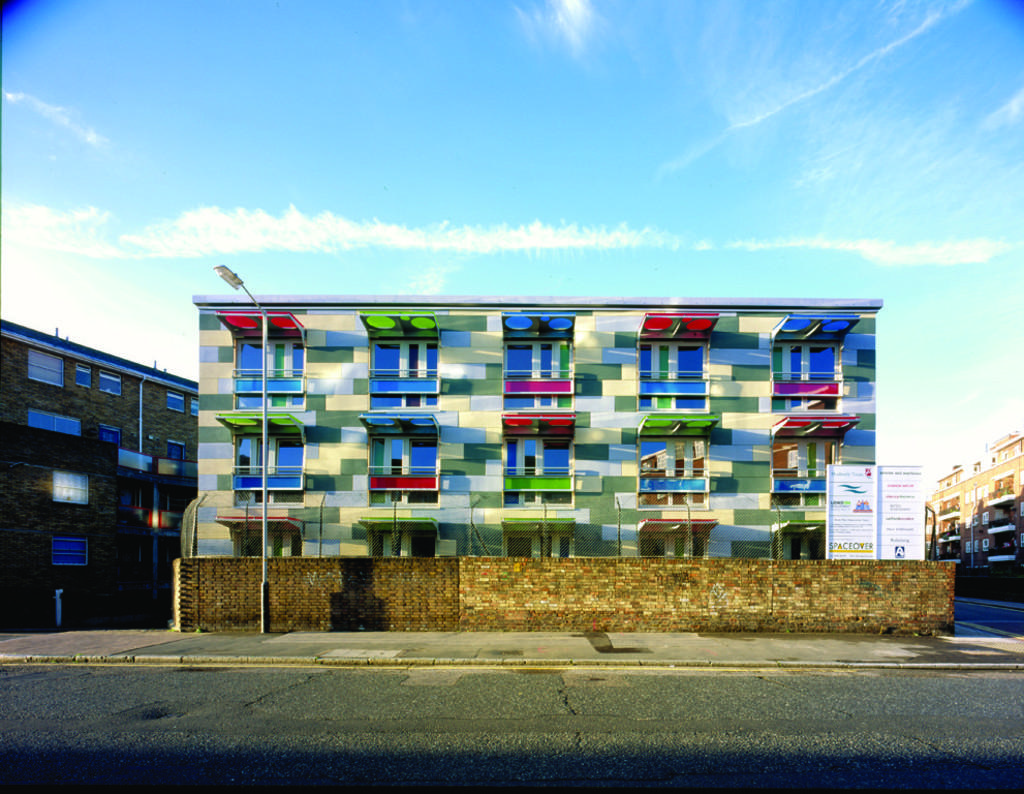What is the main subject in the center of the image? There is a building in the center of the image. Are there any other buildings visible in the image? Yes, there are other buildings on the right side and the left side of the image. What advice is the building on the left side of the image giving to the building on the right side of the image? Buildings do not give advice, as they are inanimate objects. 